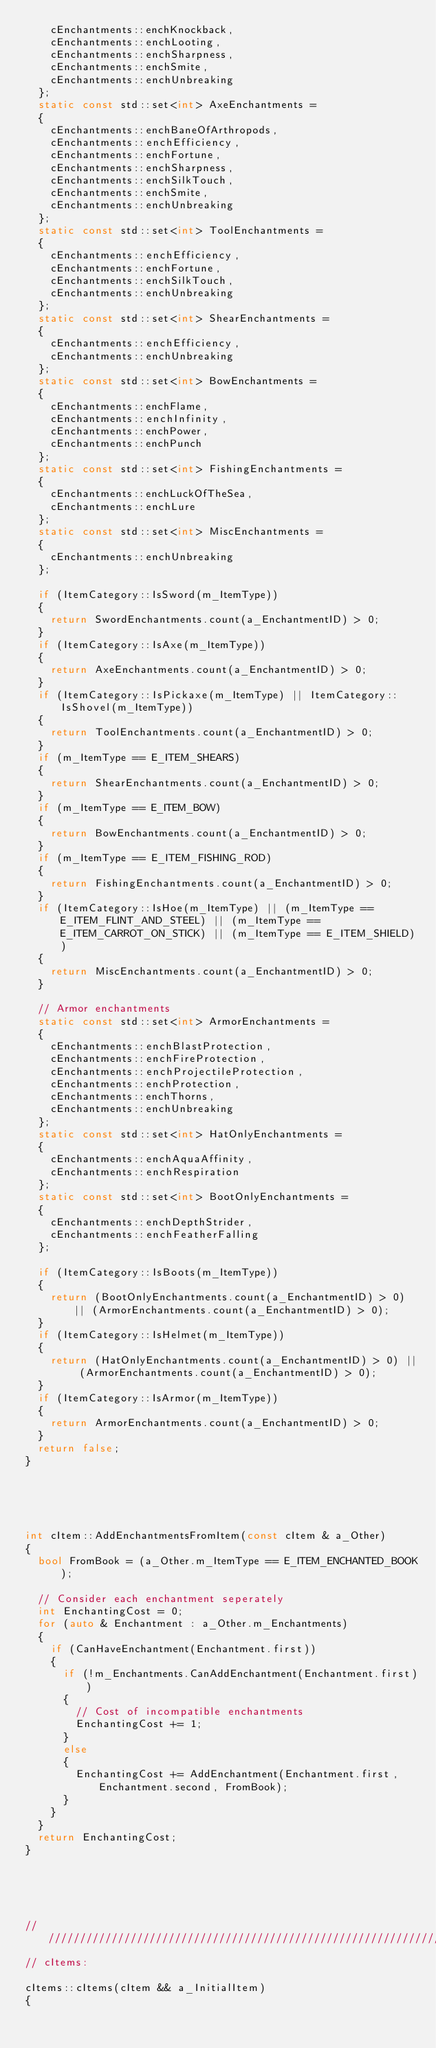<code> <loc_0><loc_0><loc_500><loc_500><_C++_>		cEnchantments::enchKnockback,
		cEnchantments::enchLooting,
		cEnchantments::enchSharpness,
		cEnchantments::enchSmite,
		cEnchantments::enchUnbreaking
	};
	static const std::set<int> AxeEnchantments =
	{
		cEnchantments::enchBaneOfArthropods,
		cEnchantments::enchEfficiency,
		cEnchantments::enchFortune,
		cEnchantments::enchSharpness,
		cEnchantments::enchSilkTouch,
		cEnchantments::enchSmite,
		cEnchantments::enchUnbreaking
	};
	static const std::set<int> ToolEnchantments =
	{
		cEnchantments::enchEfficiency,
		cEnchantments::enchFortune,
		cEnchantments::enchSilkTouch,
		cEnchantments::enchUnbreaking
	};
	static const std::set<int> ShearEnchantments =
	{
		cEnchantments::enchEfficiency,
		cEnchantments::enchUnbreaking
	};
	static const std::set<int> BowEnchantments =
	{
		cEnchantments::enchFlame,
		cEnchantments::enchInfinity,
		cEnchantments::enchPower,
		cEnchantments::enchPunch
	};
	static const std::set<int> FishingEnchantments =
	{
		cEnchantments::enchLuckOfTheSea,
		cEnchantments::enchLure
	};
	static const std::set<int> MiscEnchantments =
	{
		cEnchantments::enchUnbreaking
	};

	if (ItemCategory::IsSword(m_ItemType))
	{
		return SwordEnchantments.count(a_EnchantmentID) > 0;
	}
	if (ItemCategory::IsAxe(m_ItemType))
	{
		return AxeEnchantments.count(a_EnchantmentID) > 0;
	}
	if (ItemCategory::IsPickaxe(m_ItemType) || ItemCategory::IsShovel(m_ItemType))
	{
		return ToolEnchantments.count(a_EnchantmentID) > 0;
	}
	if (m_ItemType == E_ITEM_SHEARS)
	{
		return ShearEnchantments.count(a_EnchantmentID) > 0;
	}
	if (m_ItemType == E_ITEM_BOW)
	{
		return BowEnchantments.count(a_EnchantmentID) > 0;
	}
	if (m_ItemType == E_ITEM_FISHING_ROD)
	{
		return FishingEnchantments.count(a_EnchantmentID) > 0;
	}
	if (ItemCategory::IsHoe(m_ItemType) || (m_ItemType == E_ITEM_FLINT_AND_STEEL) || (m_ItemType == E_ITEM_CARROT_ON_STICK) || (m_ItemType == E_ITEM_SHIELD))
	{
		return MiscEnchantments.count(a_EnchantmentID) > 0;
	}

	// Armor enchantments
	static const std::set<int> ArmorEnchantments =
	{
		cEnchantments::enchBlastProtection,
		cEnchantments::enchFireProtection,
		cEnchantments::enchProjectileProtection,
		cEnchantments::enchProtection,
		cEnchantments::enchThorns,
		cEnchantments::enchUnbreaking
	};
	static const std::set<int> HatOnlyEnchantments =
	{
		cEnchantments::enchAquaAffinity,
		cEnchantments::enchRespiration
	};
	static const std::set<int> BootOnlyEnchantments =
	{
		cEnchantments::enchDepthStrider,
		cEnchantments::enchFeatherFalling
	};

	if (ItemCategory::IsBoots(m_ItemType))
	{
		return (BootOnlyEnchantments.count(a_EnchantmentID) > 0) || (ArmorEnchantments.count(a_EnchantmentID) > 0);
	}
	if (ItemCategory::IsHelmet(m_ItemType))
	{
		return (HatOnlyEnchantments.count(a_EnchantmentID) > 0) || (ArmorEnchantments.count(a_EnchantmentID) > 0);
	}
	if (ItemCategory::IsArmor(m_ItemType))
	{
		return ArmorEnchantments.count(a_EnchantmentID) > 0;
	}
	return false;
}





int cItem::AddEnchantmentsFromItem(const cItem & a_Other)
{
	bool FromBook = (a_Other.m_ItemType == E_ITEM_ENCHANTED_BOOK);

	// Consider each enchantment seperately
	int EnchantingCost = 0;
	for (auto & Enchantment : a_Other.m_Enchantments)
	{
		if (CanHaveEnchantment(Enchantment.first))
		{
			if (!m_Enchantments.CanAddEnchantment(Enchantment.first))
			{
				// Cost of incompatible enchantments
				EnchantingCost += 1;
			}
			else
			{
				EnchantingCost += AddEnchantment(Enchantment.first, Enchantment.second, FromBook);
			}
		}
	}
	return EnchantingCost;
}





////////////////////////////////////////////////////////////////////////////////
// cItems:

cItems::cItems(cItem && a_InitialItem)
{</code> 